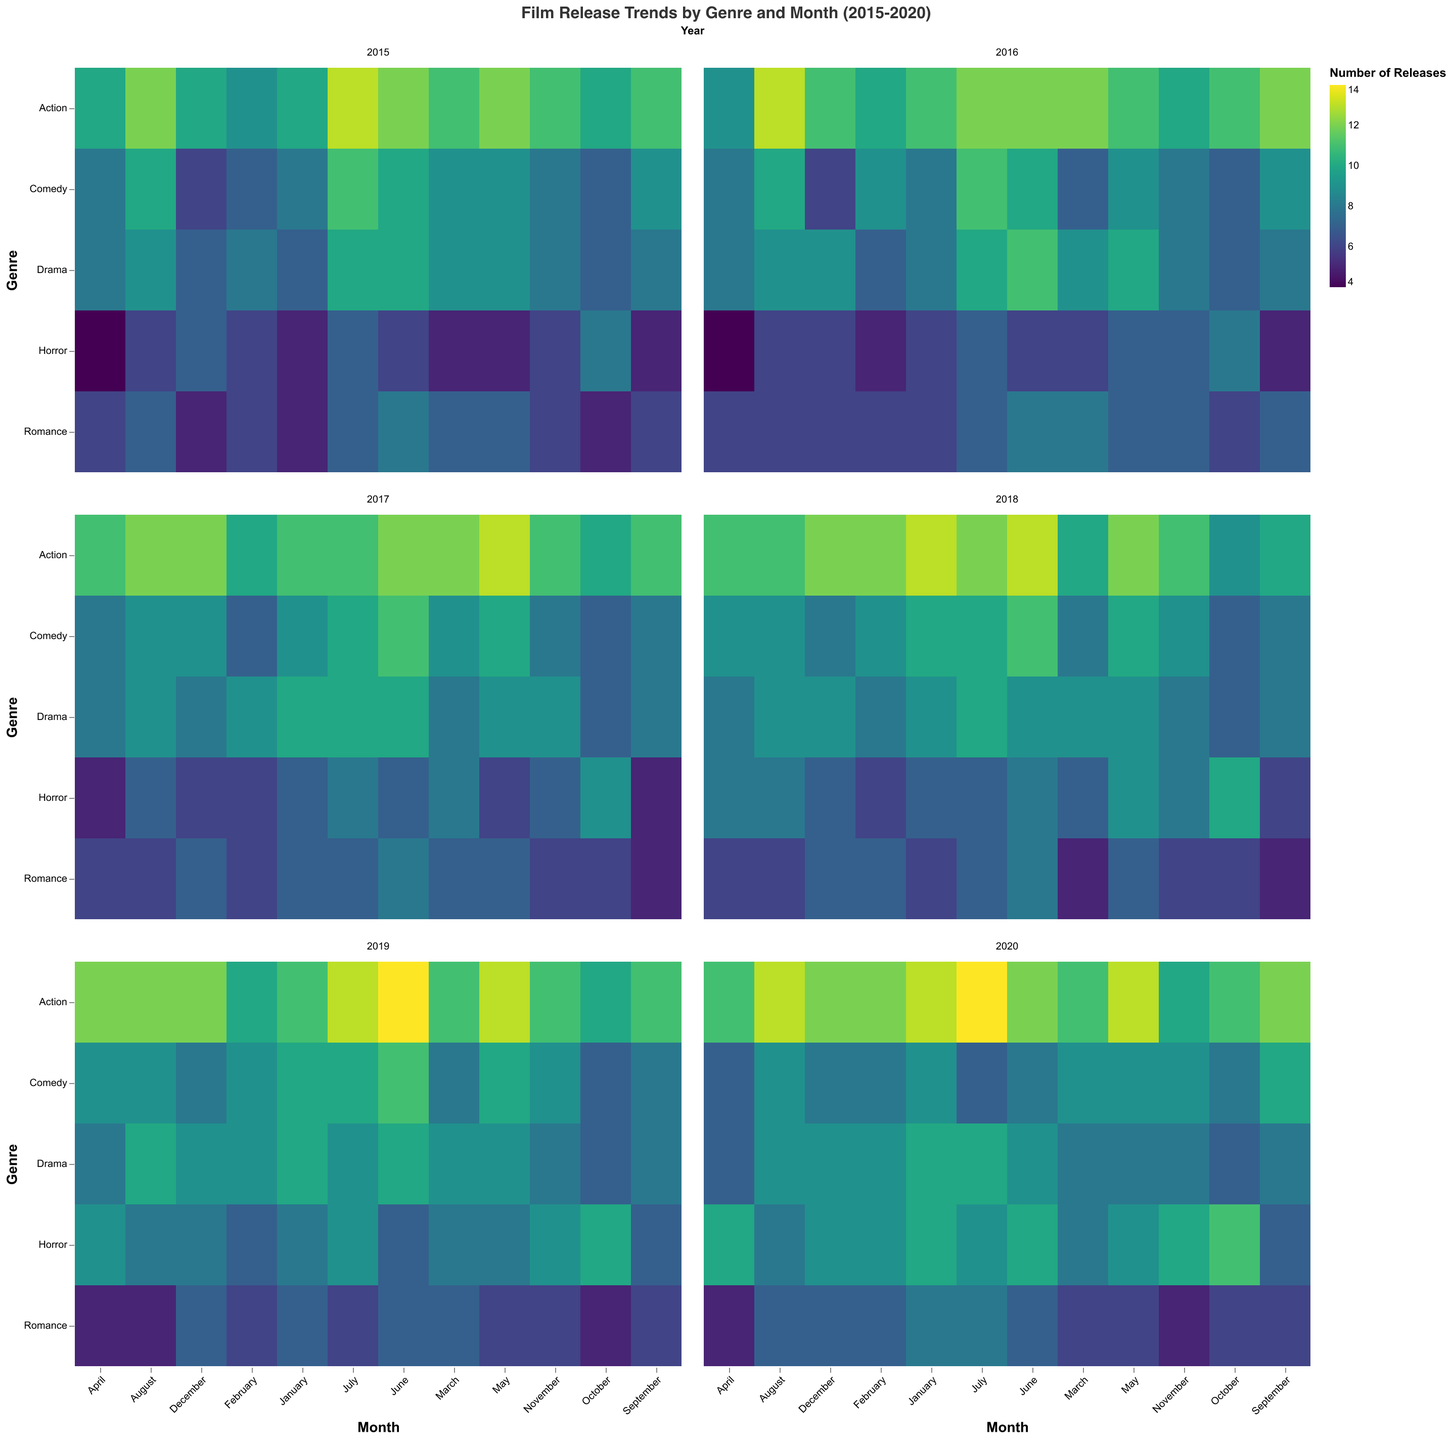What is the highest number of horror movie releases in a month within the 2015-2020 period? To find this, look at the "Horror" genre across all months and years. The maximum number of releases is 11 in October 2020.
Answer: 11 Which year had the highest number of horror movie releases in October? Compare the "Horror" genre in October for each year. In 2020, 11 horror movies were released, which is the highest.
Answer: 2020 In which month and year was the lowest number of horror movies released? Look at the "Horror" values across all months and years. The lowest value is 4 horror movies released in April 2015 and April 2016.
Answer: April 2015 and April 2016 How many horror movies were released in total in 2018? Find the "Horror" values for each month in 2018 and sum them: 7 + 6 + 7 + 8 + 9 + 8 + 7 + 8 + 6 + 10 + 8 + 7 = 91.
Answer: 91 Comparing January releases, in which year was more emphasis placed on horror movies: 2015 or 2020? Compare the number of horror movie releases in January for 2015 and 2020: 5 in 2015 and 10 in 2020.
Answer: 2020 Which genre had the most consistent number of releases across all years and months? Inspect each genre's color gradient in the heatmap. "Romance" seems to have a less varied color range, indicating consistent releases.
Answer: Romance What is the average number of horror movie releases in November across six years? Sum the "Horror" values for November from 2015 to 2020 and divide by 6: (6 + 7 + 7 + 8 + 9 + 10) / 6 = 7.83.
Answer: 7.83 Which year saw the highest overall number of horror movie releases? Sum the "Horror" values for each year and compare. For example, 2020 has the highest sum: 10 + 9 + 8 + 10 + 9 + 10 + 9 + 8 + 7 + 11 + 10 + 9 = 110.
Answer: 2020 During which month in 2019 was the highest number of action movies released? Look at the "Action" values for each month in 2019. The highest number is 14 in June 2019.
Answer: June 